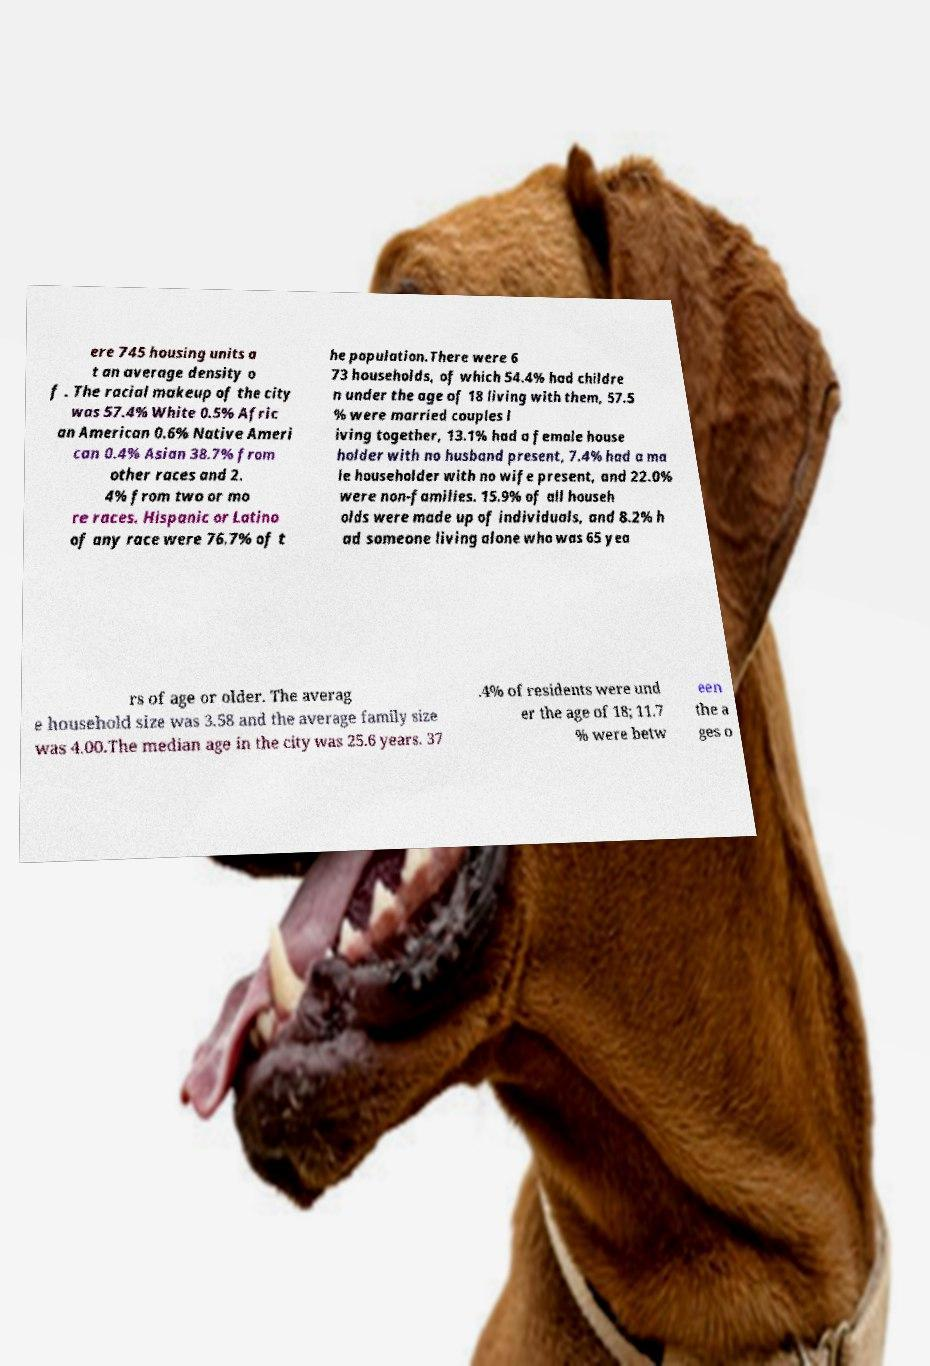Could you extract and type out the text from this image? ere 745 housing units a t an average density o f . The racial makeup of the city was 57.4% White 0.5% Afric an American 0.6% Native Ameri can 0.4% Asian 38.7% from other races and 2. 4% from two or mo re races. Hispanic or Latino of any race were 76.7% of t he population.There were 6 73 households, of which 54.4% had childre n under the age of 18 living with them, 57.5 % were married couples l iving together, 13.1% had a female house holder with no husband present, 7.4% had a ma le householder with no wife present, and 22.0% were non-families. 15.9% of all househ olds were made up of individuals, and 8.2% h ad someone living alone who was 65 yea rs of age or older. The averag e household size was 3.58 and the average family size was 4.00.The median age in the city was 25.6 years. 37 .4% of residents were und er the age of 18; 11.7 % were betw een the a ges o 